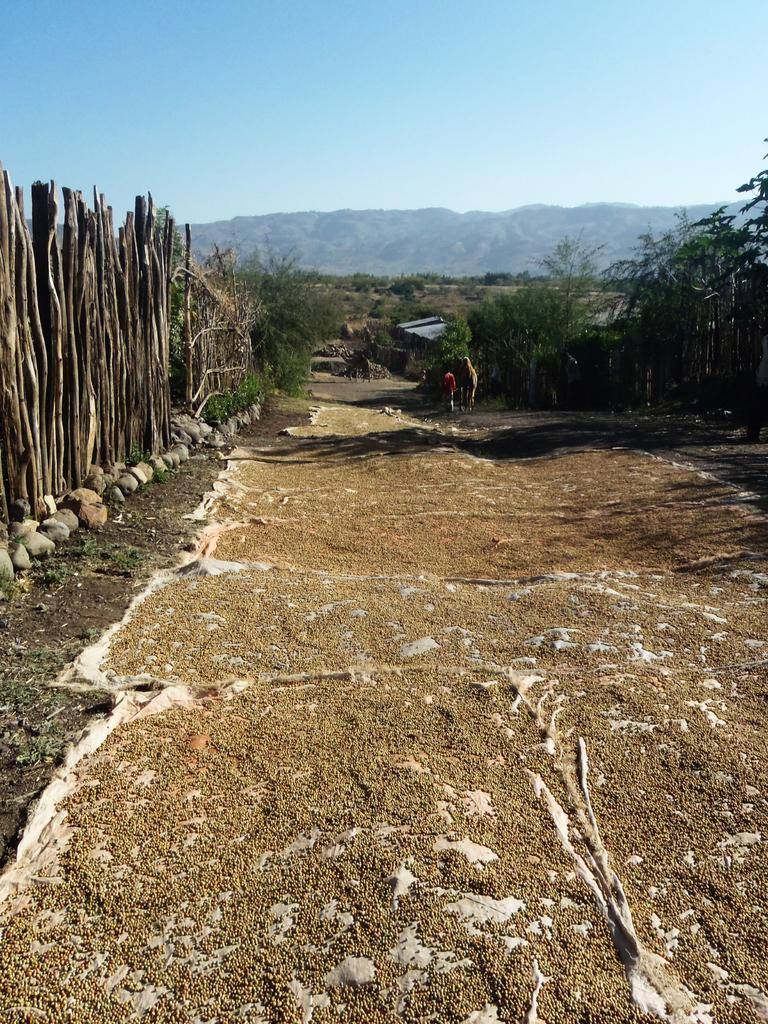What type of path is visible in the image? There is a walkway in the image. What can be seen on the surface of the walkway? There are objects placed on the surface of the walkway. What type of natural scenery is visible in the background of the image? There are trees and mountains in the background of the image. What is the condition of the sky in the image? The sky is clear and visible in the background of the image. What type of cherries are being used to flavor the objects on the walkway? There is no mention of cherries or flavoring in the image. The image only shows a walkway with objects placed on its surface, trees and mountains in the background, and a clear sky. 